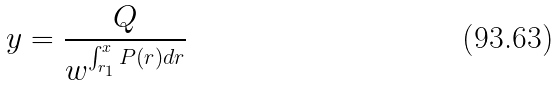Convert formula to latex. <formula><loc_0><loc_0><loc_500><loc_500>y = \frac { Q } { w ^ { \int _ { r _ { 1 } } ^ { x } P ( r ) d r } }</formula> 